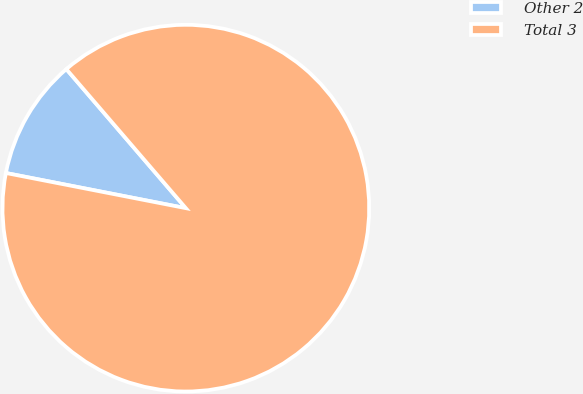Convert chart to OTSL. <chart><loc_0><loc_0><loc_500><loc_500><pie_chart><fcel>Other 2<fcel>Total 3<nl><fcel>10.63%<fcel>89.37%<nl></chart> 